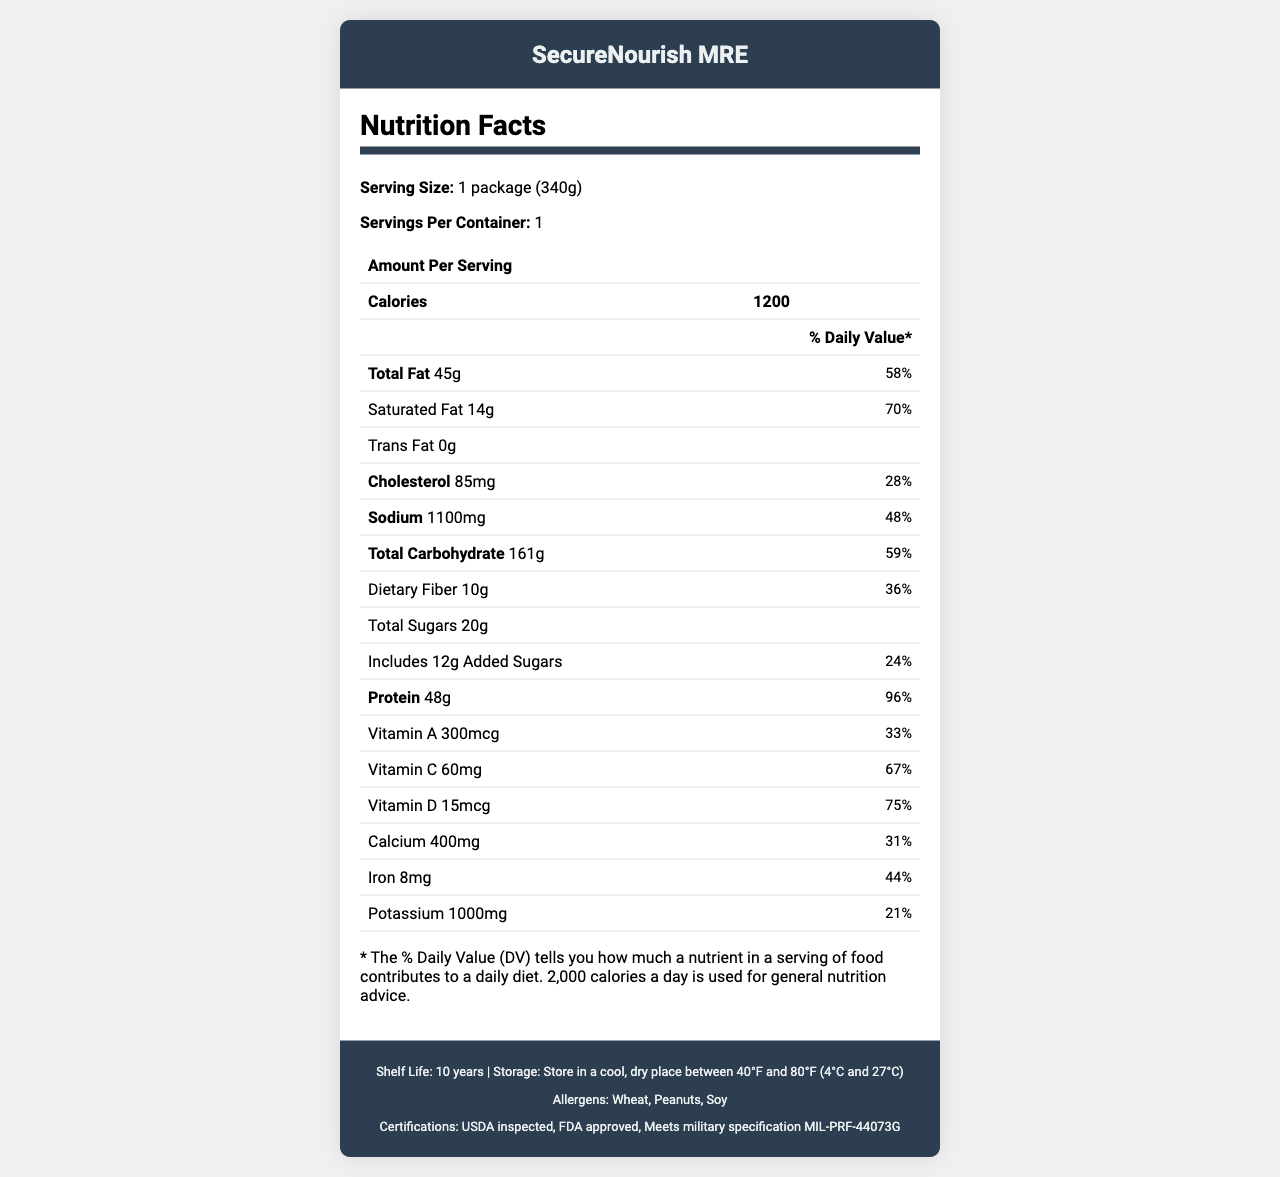what is the serving size of SecureNourish MRE? The serving size is clearly stated in the "Serving Size" section of the Nutrition Facts.
Answer: 1 package (340g) how many calories are contained in one package? The "Calories" row states the caloric content as 1200 per serving.
Answer: 1200 what is the total fat content in grams? The "Total Fat" row specifies the amount as 45 grams.
Answer: 45g what is the amount of protein per serving? The "Protein" row indicates 48 grams of protein per serving.
Answer: 48g what are the dietary fiber amounts in grams? The "Dietary Fiber" row shows 10 grams of dietary fiber.
Answer: 10g what is the percentage of daily value for calcium? A. 31% B. 36% C. 44% D. 48% The "Calcium" row specifies the daily value as 31%.
Answer: A which of the following allergens are present in the SecureNourish MRE? A. Dairy B. Peanuts C. Eggs D. Shellfish The "Allergens" section lists wheat, peanuts, and soy, making "Peanuts" the correct option.
Answer: B is there any trans fat in the SecureNourish MRE? The "Trans Fat" row indicates 0 grams, meaning there is no trans fat in this product.
Answer: No does the product have certifications indicating health and safety inspections? The document lists multiple certifications, including USDA inspected and FDA approved.
Answer: Yes summarize the main nutritional content and features of SecureNourish MRE. The document details the significant nutritional information of SecureNourish MRE, the included utensils and packaging features, and various certifications ensuring product quality.
Answer: SecureNourish MRE is a long-shelf-life meal designed for secure facility stockpiles, containing 1200 calories per package. It has 45g of total fat, 14g of saturated fat, no trans fat, 85mg of cholesterol, 1100mg of sodium, 161g of carbohydrates, 10g of dietary fiber, 20g of total sugars with 12g added sugars, and 48g of protein. The package includes essential vitamins and minerals, and comes with utensils and napkin. The product is USDA inspected, FDA approved, and meets military specifications. what are the exact proportions of enriched wheat flour and dehydrated vegetables in SecureNourish MRE? The document lists "Enriched wheat flour" and "Dehydrated vegetables" in the main ingredients, but does not provide specific proportions for each component.
Answer: Cannot be determined 